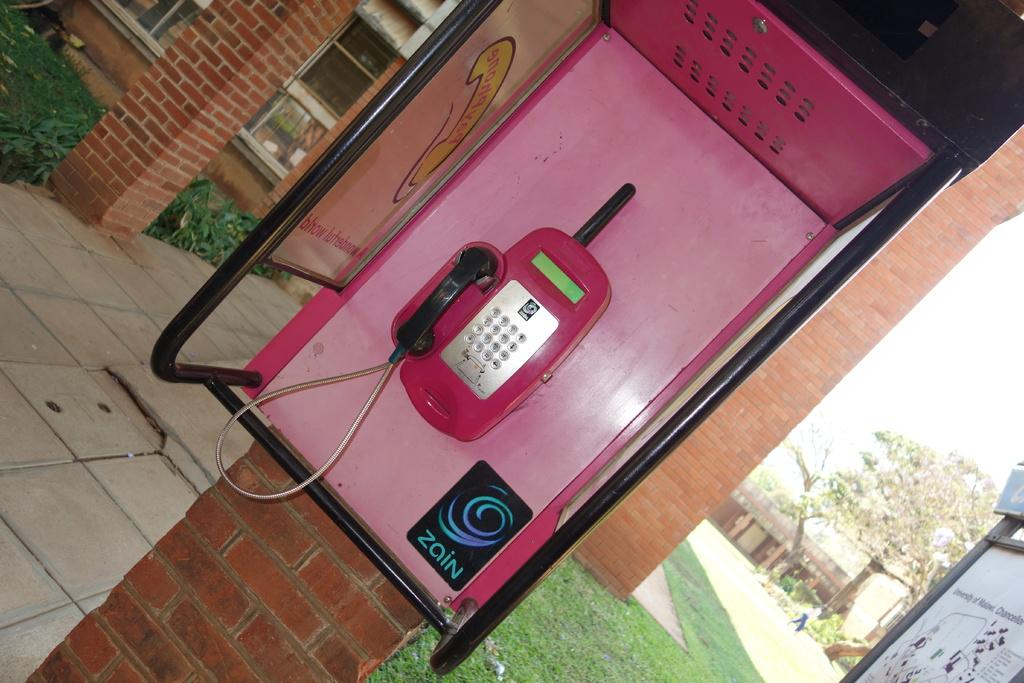<image>
Write a terse but informative summary of the picture. Pink phone that have a zain symbol at the bottom 